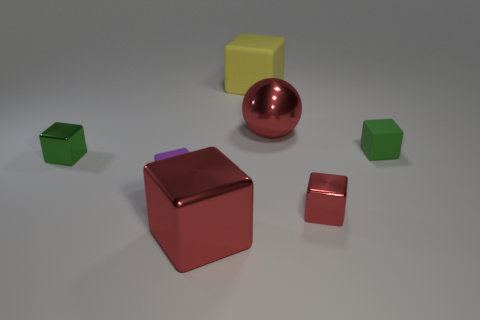Is the yellow object the same shape as the green shiny thing?
Your response must be concise. Yes. What number of large things are brown metallic balls or purple cubes?
Give a very brief answer. 0. Are there more blue blocks than tiny shiny things?
Give a very brief answer. No. There is a sphere that is the same material as the big red block; what size is it?
Your answer should be very brief. Large. Do the cube that is behind the red metallic ball and the rubber cube that is to the right of the large ball have the same size?
Keep it short and to the point. No. What number of objects are red objects that are behind the big shiny block or tiny brown cylinders?
Give a very brief answer. 2. Is the number of blocks less than the number of blue metal objects?
Offer a terse response. No. There is a small rubber object behind the small rubber cube that is to the left of the red thing on the left side of the yellow matte cube; what shape is it?
Ensure brevity in your answer.  Cube. What shape is the big object that is the same color as the shiny sphere?
Give a very brief answer. Cube. Are any matte cubes visible?
Your answer should be compact. Yes. 